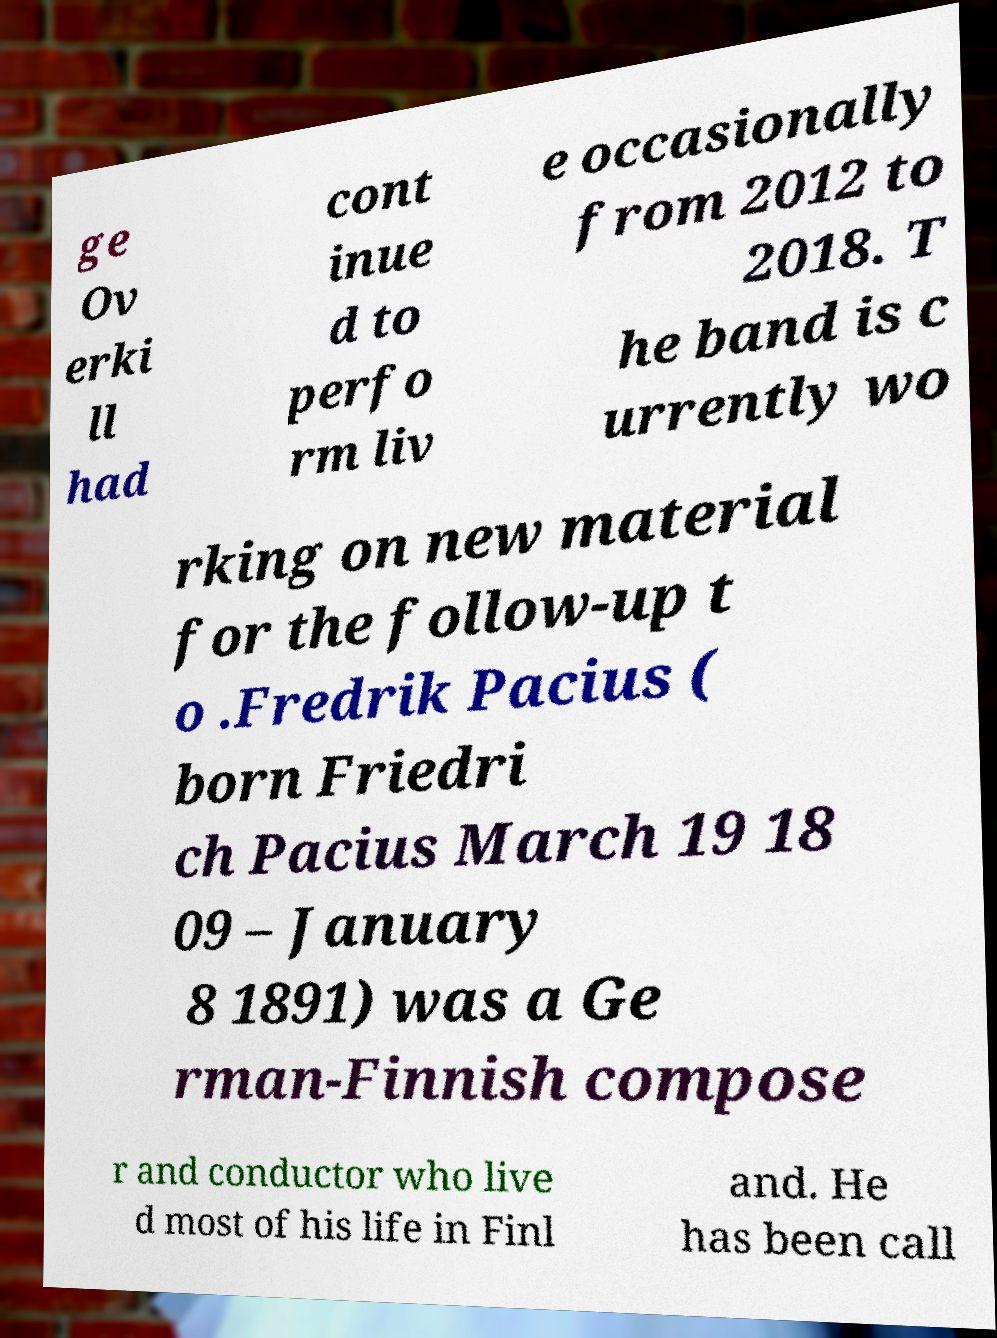There's text embedded in this image that I need extracted. Can you transcribe it verbatim? ge Ov erki ll had cont inue d to perfo rm liv e occasionally from 2012 to 2018. T he band is c urrently wo rking on new material for the follow-up t o .Fredrik Pacius ( born Friedri ch Pacius March 19 18 09 – January 8 1891) was a Ge rman-Finnish compose r and conductor who live d most of his life in Finl and. He has been call 